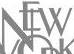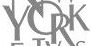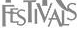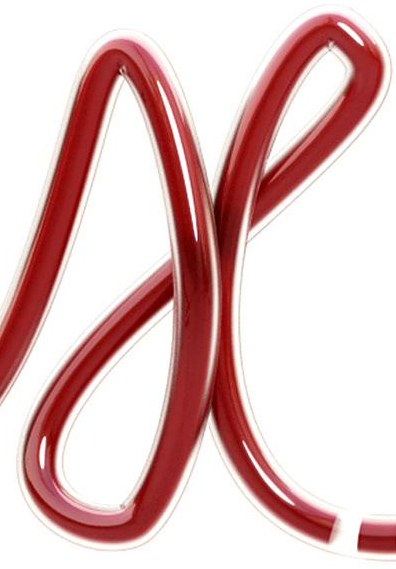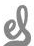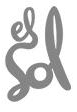Read the text content from these images in order, separated by a semicolon. NEW; YORK; FESTIVALS; X; el; Sol 